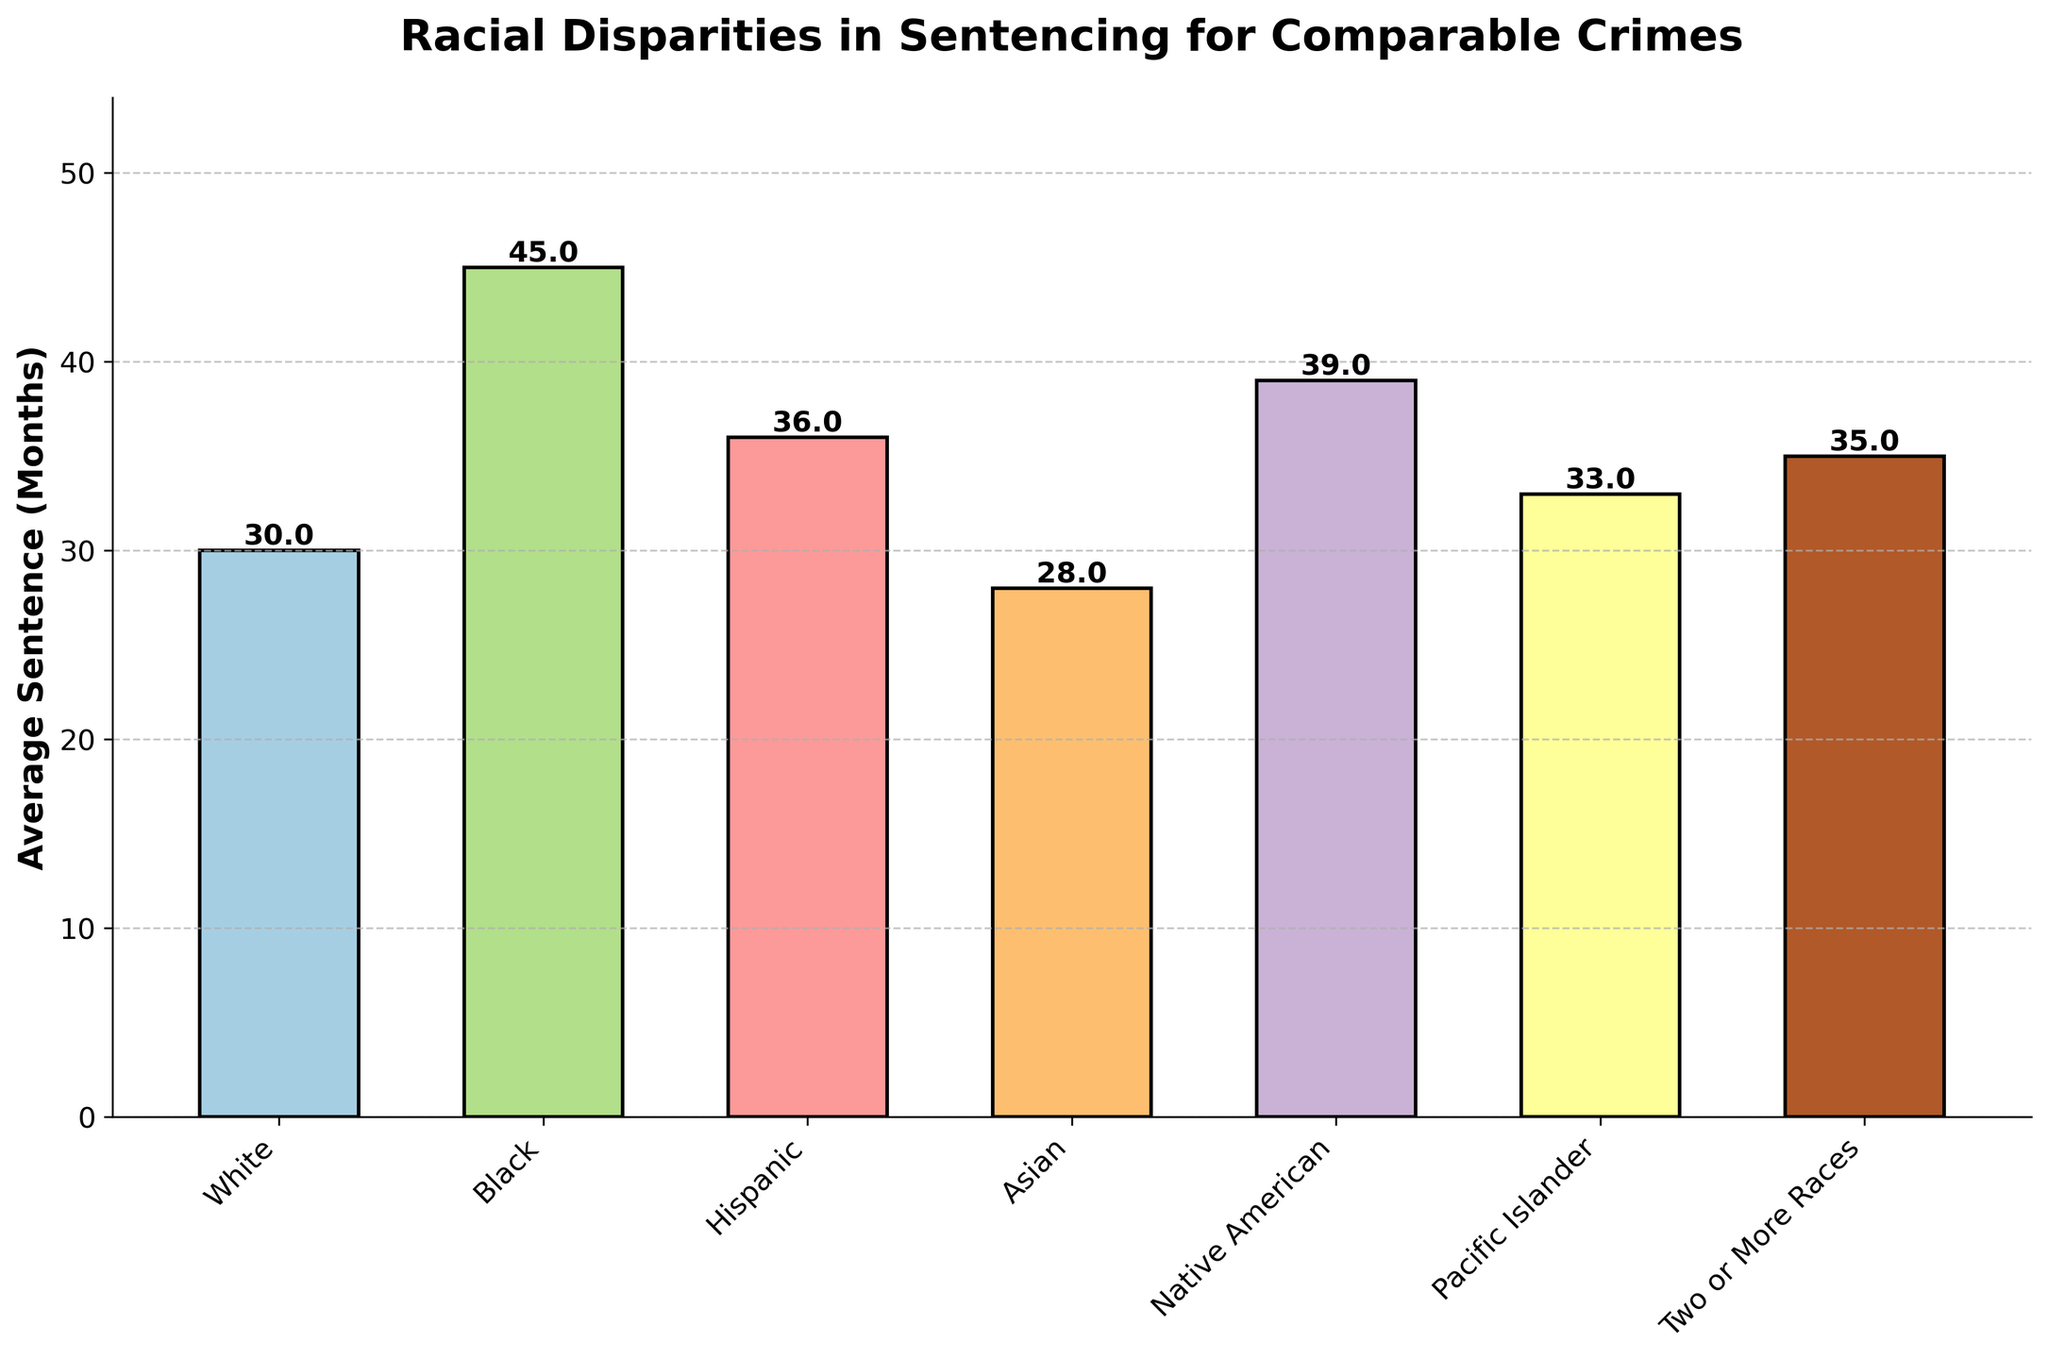Which race has the highest average sentence? By looking at the height of the bars, the Black race has the tallest bar, indicating the highest average sentence length.
Answer: Black What is the difference in average sentences between the White and Black races? The White race has an average sentence of 30 months while the Black race has 45 months. The difference is 45 - 30 = 15.
Answer: 15 months How does the average sentence for the Asian race compare to that of the Hispanic race? The Asian race has an average sentence of 28 months whereas the Hispanic race has 36 months. The Hispanic race has a longer average sentence.
Answer: Hispanic is longer Which race has an average sentence closest to 35 months? Two or More Races has an average sentence of 35 months, which matches exactly.
Answer: Two or More Races Are there any races with an average sentence less than 30 months? By looking at the bars, only the Asian race has an average sentence of 28 months, which is less than 30 months.
Answer: Asian What is the combined average sentence for White and Pacific Islander races? The White race has an average sentence of 30 months and the Pacific Islander race has 33 months. The combined average is (30 + 33) / 2 = 31.5 months.
Answer: 31.5 months Identify the second highest average sentence in the chart. The highest is for Black at 45 months. The second highest bar belongs to Native American at 39 months.
Answer: Native American What is the total average sentence for all races combined? Adding the average sentences for all races: 30 (White) + 45 (Black) + 36 (Hispanic) + 28 (Asian) + 39 (Native American) + 33 (Pacific Islander) + 35 (Two or More Races) = 246 months.
Answer: 246 months How much longer is the average sentence for Black compared to Pacific Islander? Black has an average sentence of 45 months and Pacific Islander has 33 months. The difference is 45 - 33 = 12 months.
Answer: 12 months 